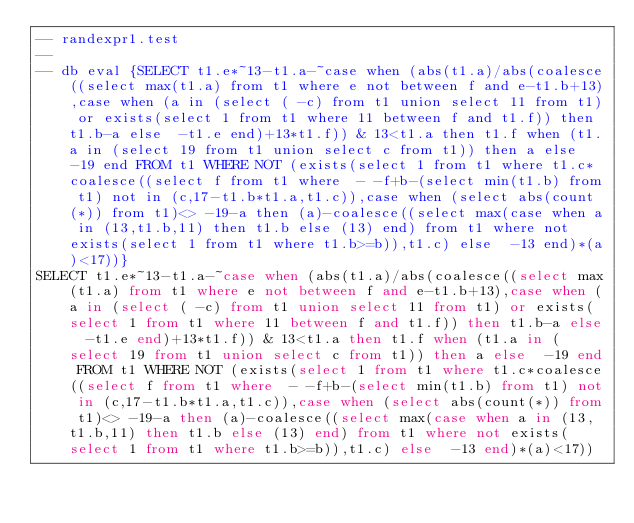Convert code to text. <code><loc_0><loc_0><loc_500><loc_500><_SQL_>-- randexpr1.test
-- 
-- db eval {SELECT t1.e*~13-t1.a-~case when (abs(t1.a)/abs(coalesce((select max(t1.a) from t1 where e not between f and e-t1.b+13),case when (a in (select ( -c) from t1 union select 11 from t1) or exists(select 1 from t1 where 11 between f and t1.f)) then t1.b-a else  -t1.e end)+13*t1.f)) & 13<t1.a then t1.f when (t1.a in (select 19 from t1 union select c from t1)) then a else  -19 end FROM t1 WHERE NOT (exists(select 1 from t1 where t1.c*coalesce((select f from t1 where  - -f+b-(select min(t1.b) from t1) not in (c,17-t1.b*t1.a,t1.c)),case when (select abs(count(*)) from t1)<> -19-a then (a)-coalesce((select max(case when a in (13,t1.b,11) then t1.b else (13) end) from t1 where not exists(select 1 from t1 where t1.b>=b)),t1.c) else  -13 end)*(a)<17))}
SELECT t1.e*~13-t1.a-~case when (abs(t1.a)/abs(coalesce((select max(t1.a) from t1 where e not between f and e-t1.b+13),case when (a in (select ( -c) from t1 union select 11 from t1) or exists(select 1 from t1 where 11 between f and t1.f)) then t1.b-a else  -t1.e end)+13*t1.f)) & 13<t1.a then t1.f when (t1.a in (select 19 from t1 union select c from t1)) then a else  -19 end FROM t1 WHERE NOT (exists(select 1 from t1 where t1.c*coalesce((select f from t1 where  - -f+b-(select min(t1.b) from t1) not in (c,17-t1.b*t1.a,t1.c)),case when (select abs(count(*)) from t1)<> -19-a then (a)-coalesce((select max(case when a in (13,t1.b,11) then t1.b else (13) end) from t1 where not exists(select 1 from t1 where t1.b>=b)),t1.c) else  -13 end)*(a)<17))</code> 